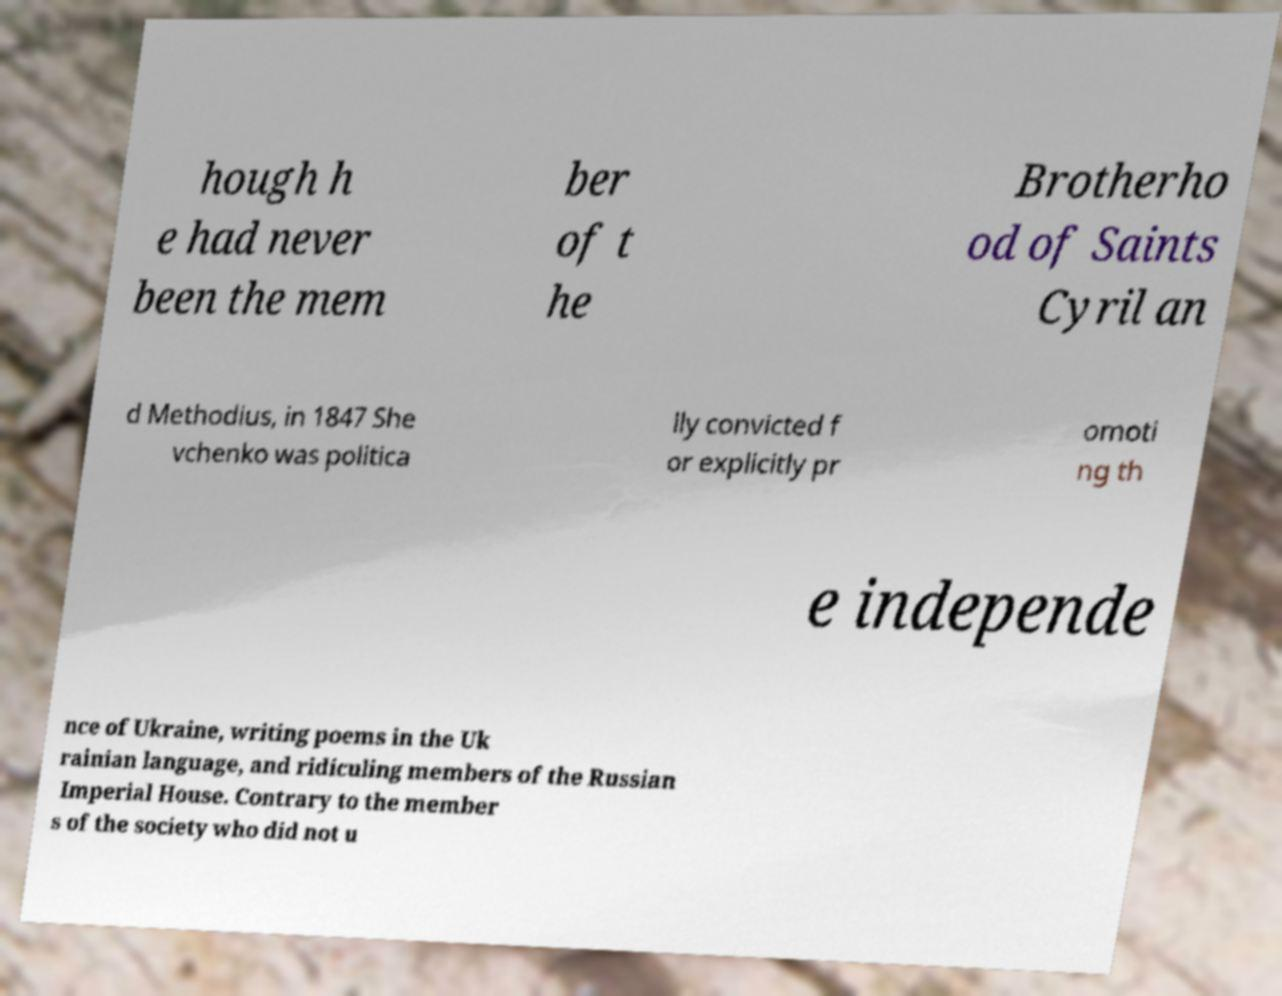Please identify and transcribe the text found in this image. hough h e had never been the mem ber of t he Brotherho od of Saints Cyril an d Methodius, in 1847 She vchenko was politica lly convicted f or explicitly pr omoti ng th e independe nce of Ukraine, writing poems in the Uk rainian language, and ridiculing members of the Russian Imperial House. Contrary to the member s of the society who did not u 